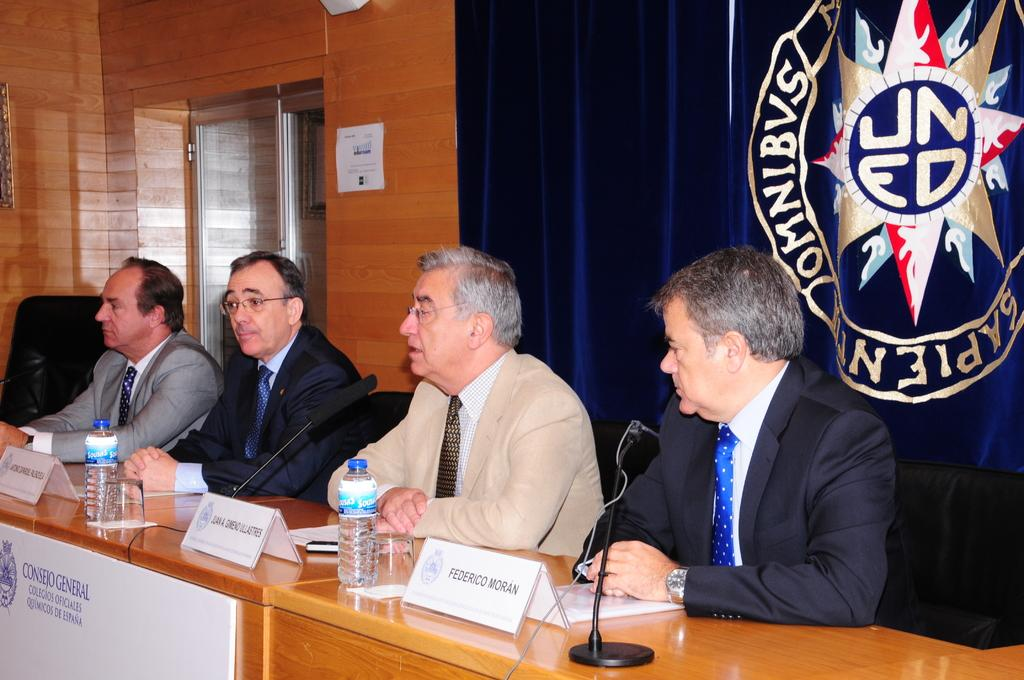<image>
Summarize the visual content of the image. The panel of four gentlemen includes Federico Moran whom is sitting at the far right. 